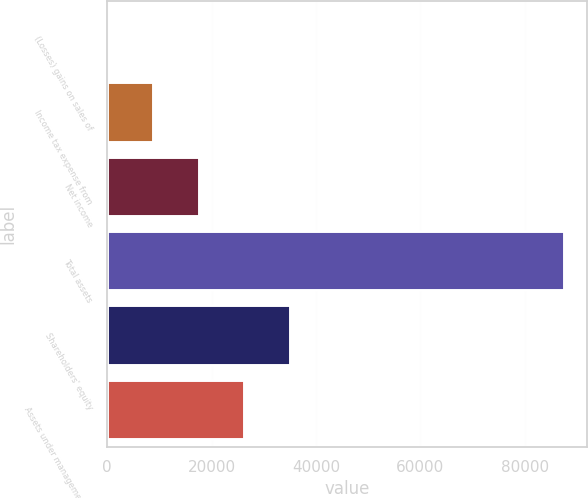<chart> <loc_0><loc_0><loc_500><loc_500><bar_chart><fcel>(Losses) gains on sales of<fcel>Income tax expense from<fcel>Net income<fcel>Total assets<fcel>Shareholders' equity<fcel>Assets under management (in<nl><fcel>23<fcel>8774.1<fcel>17525.2<fcel>87534<fcel>35027.4<fcel>26276.3<nl></chart> 